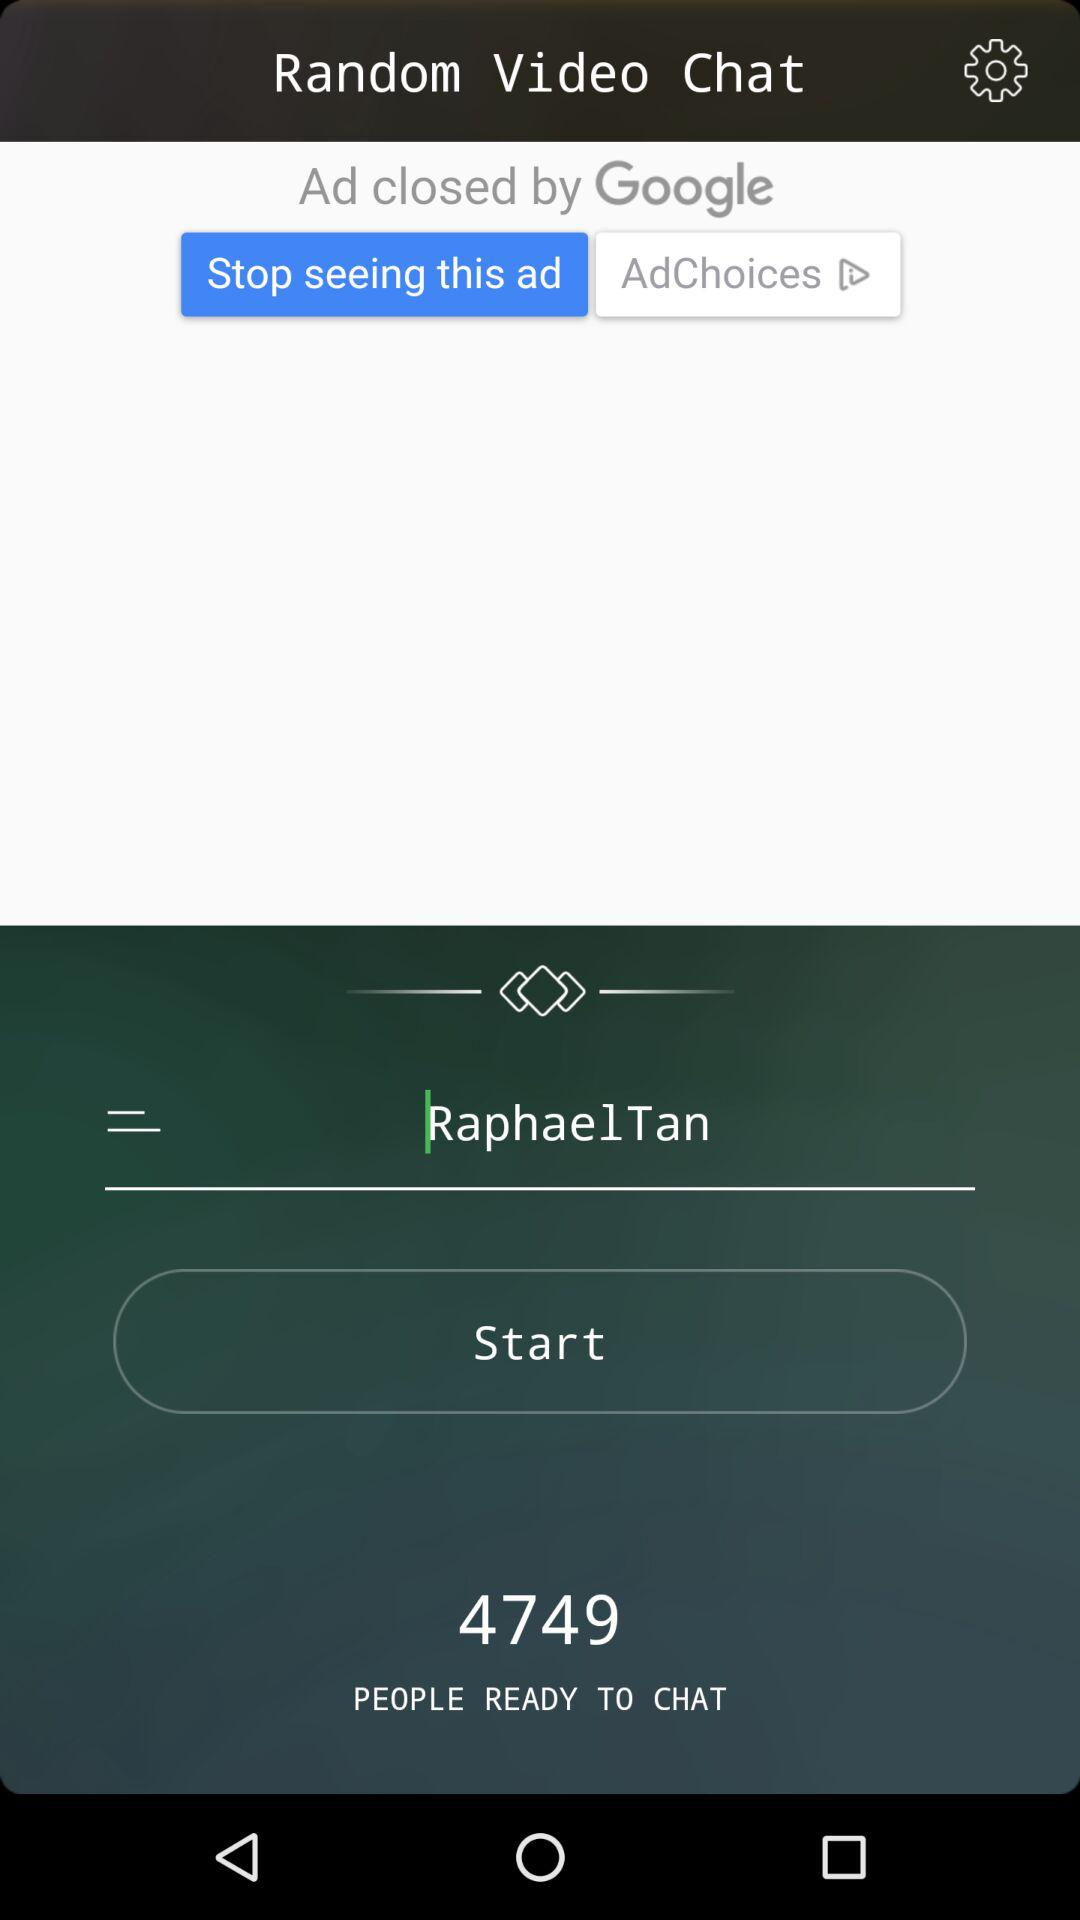How many people are ready to chat? There are 4749 people ready to chat. 